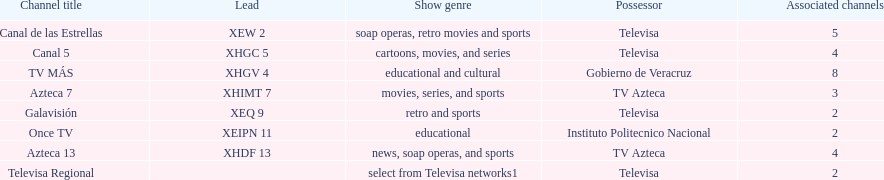Which is the only station with 8 affiliates? TV MÁS. 